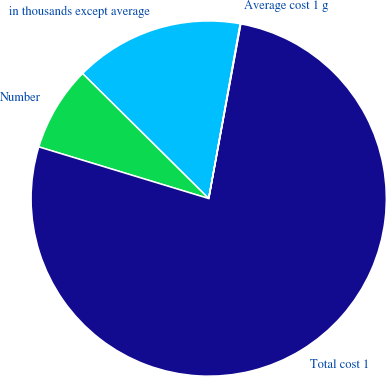Convert chart to OTSL. <chart><loc_0><loc_0><loc_500><loc_500><pie_chart><fcel>in thousands except average<fcel>Number<fcel>Total cost 1<fcel>Average cost 1 g<nl><fcel>15.41%<fcel>7.73%<fcel>76.81%<fcel>0.05%<nl></chart> 